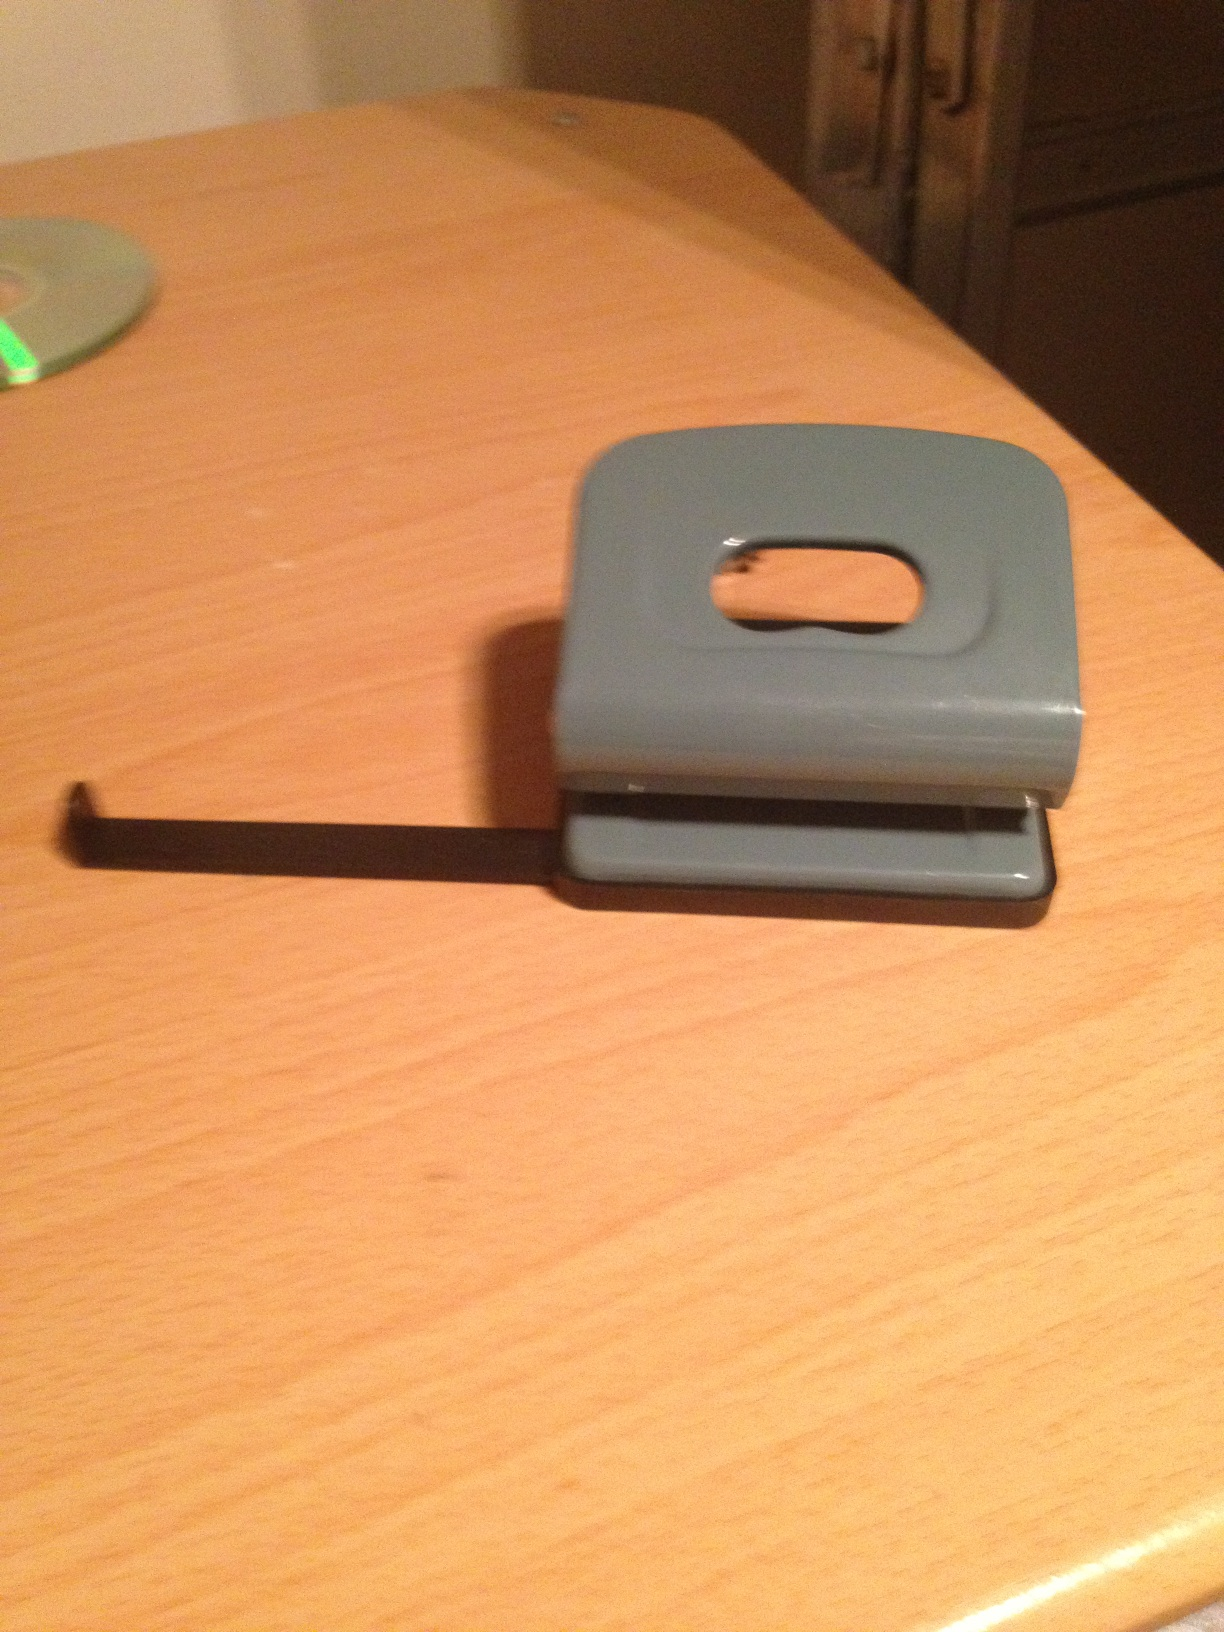What material is the hole punch made of? The hole punch in the image is made of plastic and metal. The body seems to be constructed from a durable plastic, while the actual punching mechanism is likely made of metal for durability and precision. 